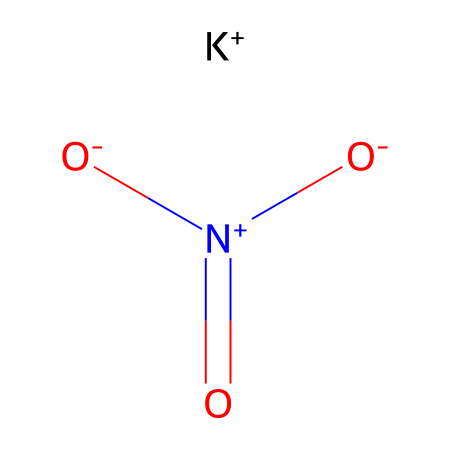What is the name of this chemical? The SMILES representation indicates the presence of potassium, nitrogen, and oxygen atoms in this compound, commonly known as potassium nitrate.
Answer: potassium nitrate How many nitrogen atoms are present in this chemical? By analyzing the SMILES string, we can identify two nitrogen atoms based on the structure.
Answer: 2 How many oxygen atoms are present in this chemical? The structure reveals a total of three oxygen atoms, as indicated by the notation in the SMILES.
Answer: 3 What type of bonding is evident in potassium nitrate? The compound shows ionic bonding between the potassium ion and the nitrate anion, which indicates that it is formed through electrostatic attraction.
Answer: ionic What is the charge of the potassium ion in this chemical? The SMILES notation includes [K+], indicating that the potassium ion has a positive charge.
Answer: positive What is the role of potassium nitrate in gunpowder? Potassium nitrate acts as an oxidizer within gunpowder, facilitating the combustion of the fuel components by providing oxygen.
Answer: oxidizer 